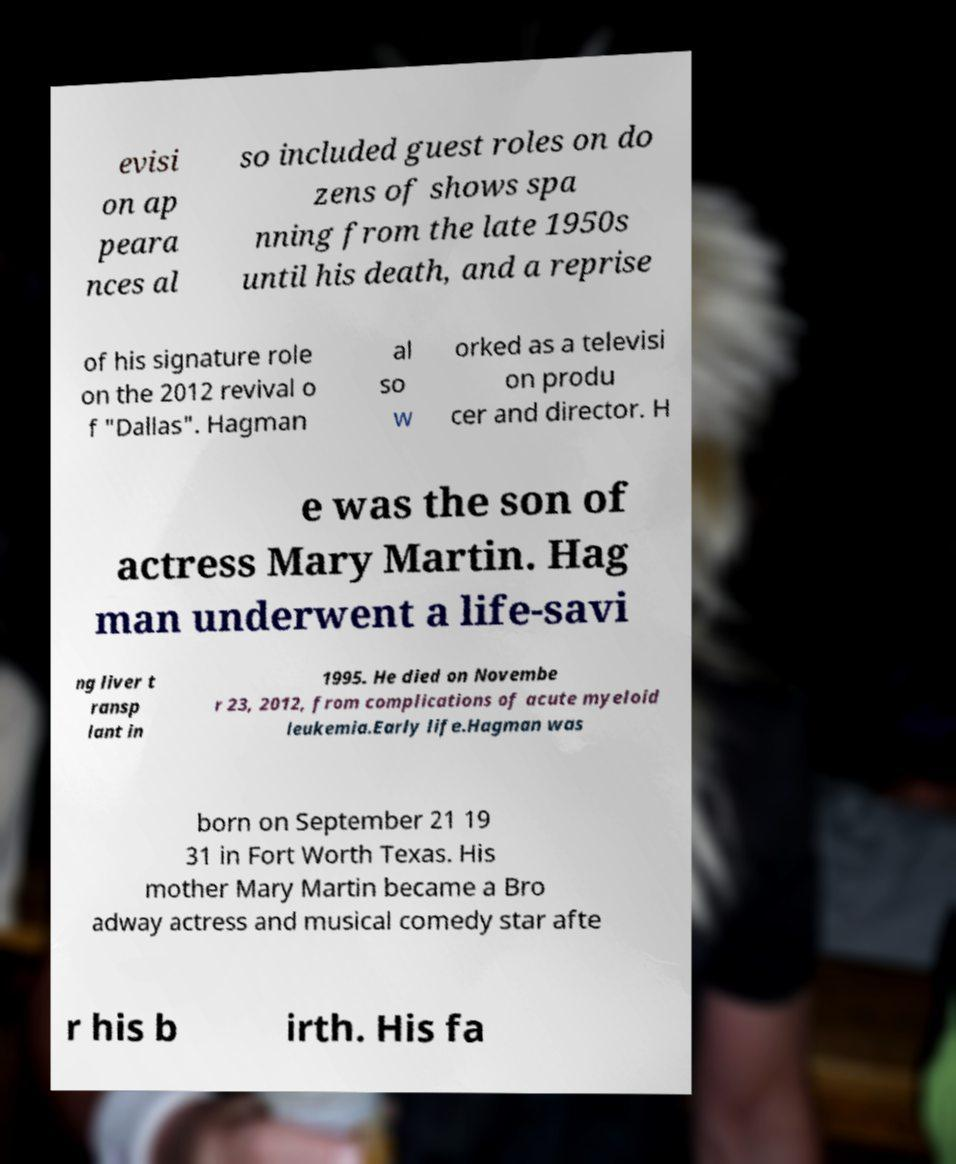Please identify and transcribe the text found in this image. evisi on ap peara nces al so included guest roles on do zens of shows spa nning from the late 1950s until his death, and a reprise of his signature role on the 2012 revival o f "Dallas". Hagman al so w orked as a televisi on produ cer and director. H e was the son of actress Mary Martin. Hag man underwent a life-savi ng liver t ransp lant in 1995. He died on Novembe r 23, 2012, from complications of acute myeloid leukemia.Early life.Hagman was born on September 21 19 31 in Fort Worth Texas. His mother Mary Martin became a Bro adway actress and musical comedy star afte r his b irth. His fa 